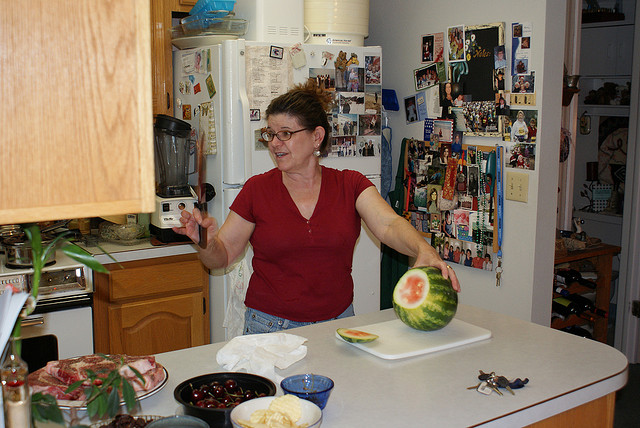Can you describe the setting of this image? The image shows a well-lived and cozy kitchen setting, characterized by numerous personal items like photographs and notes magnetically attached to the refrigerator door, indicating this may be the heart of the home where family members leave messages and memories. The counter is filled with various objects that suggest meal preparation, including watermelon, dishes, and utensils, creating a snapshot of daily life. 